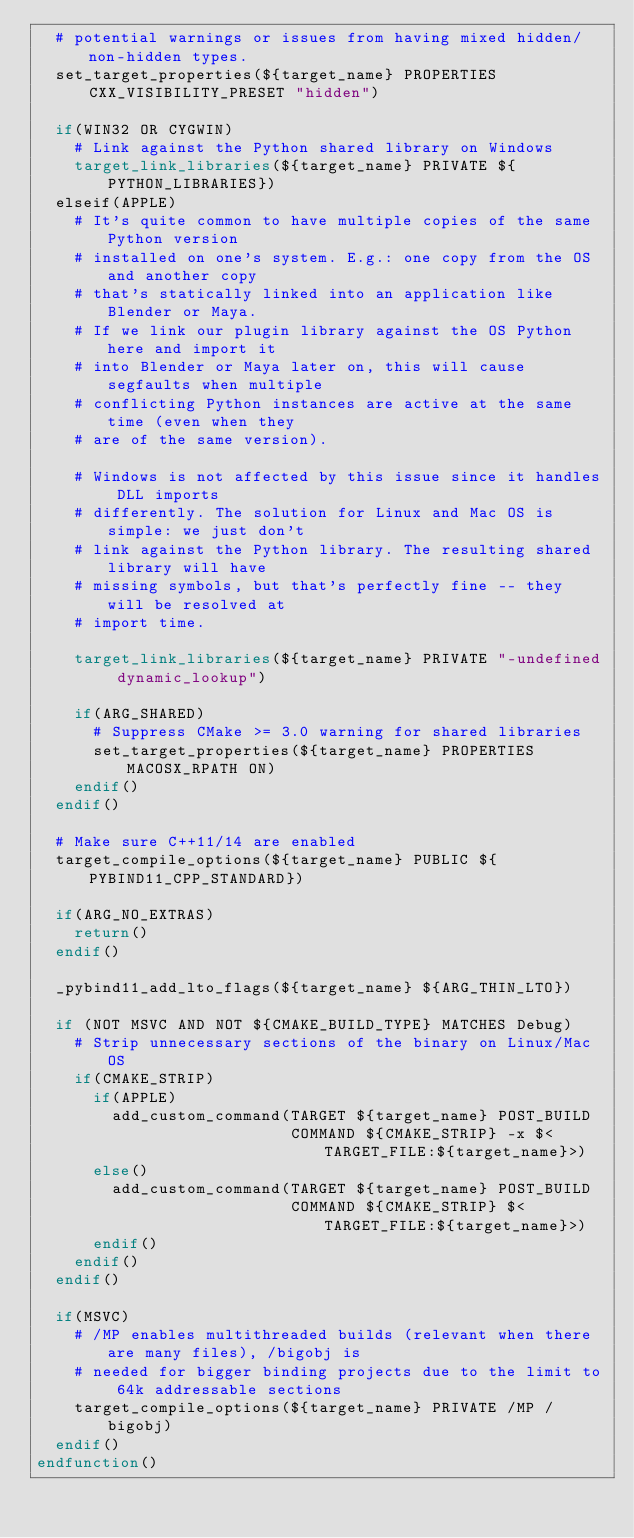<code> <loc_0><loc_0><loc_500><loc_500><_CMake_>  # potential warnings or issues from having mixed hidden/non-hidden types.
  set_target_properties(${target_name} PROPERTIES CXX_VISIBILITY_PRESET "hidden")

  if(WIN32 OR CYGWIN)
    # Link against the Python shared library on Windows
    target_link_libraries(${target_name} PRIVATE ${PYTHON_LIBRARIES})
  elseif(APPLE)
    # It's quite common to have multiple copies of the same Python version
    # installed on one's system. E.g.: one copy from the OS and another copy
    # that's statically linked into an application like Blender or Maya.
    # If we link our plugin library against the OS Python here and import it
    # into Blender or Maya later on, this will cause segfaults when multiple
    # conflicting Python instances are active at the same time (even when they
    # are of the same version).

    # Windows is not affected by this issue since it handles DLL imports
    # differently. The solution for Linux and Mac OS is simple: we just don't
    # link against the Python library. The resulting shared library will have
    # missing symbols, but that's perfectly fine -- they will be resolved at
    # import time.

    target_link_libraries(${target_name} PRIVATE "-undefined dynamic_lookup")

    if(ARG_SHARED)
      # Suppress CMake >= 3.0 warning for shared libraries
      set_target_properties(${target_name} PROPERTIES MACOSX_RPATH ON)
    endif()
  endif()

  # Make sure C++11/14 are enabled
  target_compile_options(${target_name} PUBLIC ${PYBIND11_CPP_STANDARD})

  if(ARG_NO_EXTRAS)
    return()
  endif()

  _pybind11_add_lto_flags(${target_name} ${ARG_THIN_LTO})

  if (NOT MSVC AND NOT ${CMAKE_BUILD_TYPE} MATCHES Debug)
    # Strip unnecessary sections of the binary on Linux/Mac OS
    if(CMAKE_STRIP)
      if(APPLE)
        add_custom_command(TARGET ${target_name} POST_BUILD
                           COMMAND ${CMAKE_STRIP} -x $<TARGET_FILE:${target_name}>)
      else()
        add_custom_command(TARGET ${target_name} POST_BUILD
                           COMMAND ${CMAKE_STRIP} $<TARGET_FILE:${target_name}>)
      endif()
    endif()
  endif()

  if(MSVC)
    # /MP enables multithreaded builds (relevant when there are many files), /bigobj is
    # needed for bigger binding projects due to the limit to 64k addressable sections
    target_compile_options(${target_name} PRIVATE /MP /bigobj)
  endif()
endfunction()
</code> 